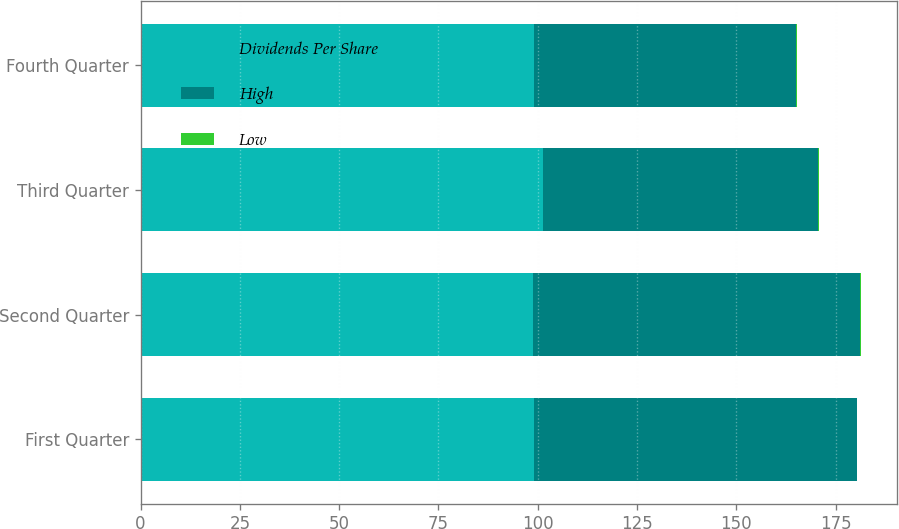Convert chart. <chart><loc_0><loc_0><loc_500><loc_500><stacked_bar_chart><ecel><fcel>First Quarter<fcel>Second Quarter<fcel>Third Quarter<fcel>Fourth Quarter<nl><fcel>Dividends Per Share<fcel>98.99<fcel>98.72<fcel>101.27<fcel>99.17<nl><fcel>High<fcel>81.27<fcel>82.5<fcel>69.25<fcel>65.91<nl><fcel>Low<fcel>0.18<fcel>0.18<fcel>0.22<fcel>0.22<nl></chart> 